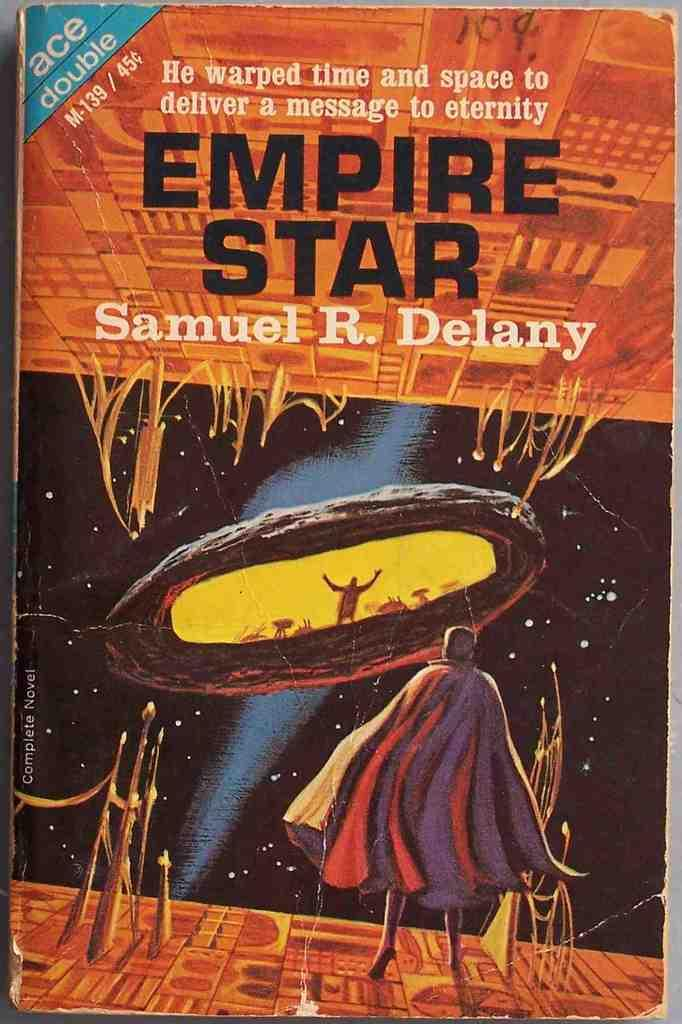<image>
Provide a brief description of the given image. A copy of the book epmire star by Samuel R. Delany. 